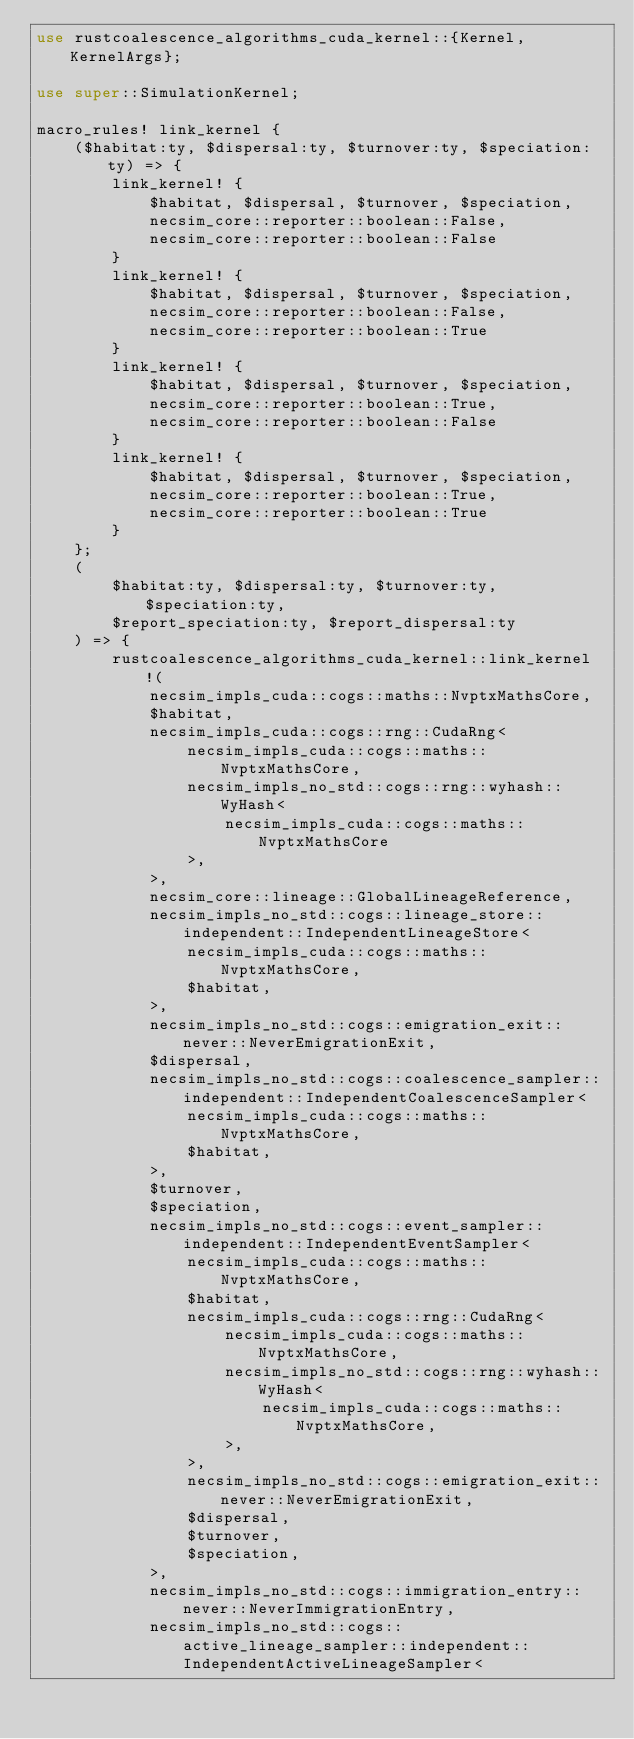<code> <loc_0><loc_0><loc_500><loc_500><_Rust_>use rustcoalescence_algorithms_cuda_kernel::{Kernel, KernelArgs};

use super::SimulationKernel;

macro_rules! link_kernel {
    ($habitat:ty, $dispersal:ty, $turnover:ty, $speciation:ty) => {
        link_kernel! {
            $habitat, $dispersal, $turnover, $speciation,
            necsim_core::reporter::boolean::False,
            necsim_core::reporter::boolean::False
        }
        link_kernel! {
            $habitat, $dispersal, $turnover, $speciation,
            necsim_core::reporter::boolean::False,
            necsim_core::reporter::boolean::True
        }
        link_kernel! {
            $habitat, $dispersal, $turnover, $speciation,
            necsim_core::reporter::boolean::True,
            necsim_core::reporter::boolean::False
        }
        link_kernel! {
            $habitat, $dispersal, $turnover, $speciation,
            necsim_core::reporter::boolean::True,
            necsim_core::reporter::boolean::True
        }
    };
    (
        $habitat:ty, $dispersal:ty, $turnover:ty, $speciation:ty,
        $report_speciation:ty, $report_dispersal:ty
    ) => {
        rustcoalescence_algorithms_cuda_kernel::link_kernel!(
            necsim_impls_cuda::cogs::maths::NvptxMathsCore,
            $habitat,
            necsim_impls_cuda::cogs::rng::CudaRng<
                necsim_impls_cuda::cogs::maths::NvptxMathsCore,
                necsim_impls_no_std::cogs::rng::wyhash::WyHash<
                    necsim_impls_cuda::cogs::maths::NvptxMathsCore
                >,
            >,
            necsim_core::lineage::GlobalLineageReference,
            necsim_impls_no_std::cogs::lineage_store::independent::IndependentLineageStore<
                necsim_impls_cuda::cogs::maths::NvptxMathsCore,
                $habitat,
            >,
            necsim_impls_no_std::cogs::emigration_exit::never::NeverEmigrationExit,
            $dispersal,
            necsim_impls_no_std::cogs::coalescence_sampler::independent::IndependentCoalescenceSampler<
                necsim_impls_cuda::cogs::maths::NvptxMathsCore,
                $habitat,
            >,
            $turnover,
            $speciation,
            necsim_impls_no_std::cogs::event_sampler::independent::IndependentEventSampler<
                necsim_impls_cuda::cogs::maths::NvptxMathsCore,
                $habitat,
                necsim_impls_cuda::cogs::rng::CudaRng<
                    necsim_impls_cuda::cogs::maths::NvptxMathsCore,
                    necsim_impls_no_std::cogs::rng::wyhash::WyHash<
                        necsim_impls_cuda::cogs::maths::NvptxMathsCore,
                    >,
                >,
                necsim_impls_no_std::cogs::emigration_exit::never::NeverEmigrationExit,
                $dispersal,
                $turnover,
                $speciation,
            >,
            necsim_impls_no_std::cogs::immigration_entry::never::NeverImmigrationEntry,
            necsim_impls_no_std::cogs::active_lineage_sampler::independent::IndependentActiveLineageSampler<</code> 